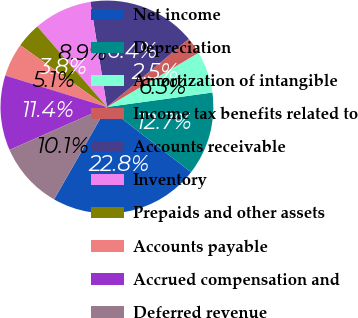Convert chart. <chart><loc_0><loc_0><loc_500><loc_500><pie_chart><fcel>Net income<fcel>Depreciation<fcel>Amortization of intangible<fcel>Income tax benefits related to<fcel>Accounts receivable<fcel>Inventory<fcel>Prepaids and other assets<fcel>Accounts payable<fcel>Accrued compensation and<fcel>Deferred revenue<nl><fcel>22.78%<fcel>12.66%<fcel>6.33%<fcel>2.54%<fcel>16.45%<fcel>8.86%<fcel>3.8%<fcel>5.07%<fcel>11.39%<fcel>10.13%<nl></chart> 